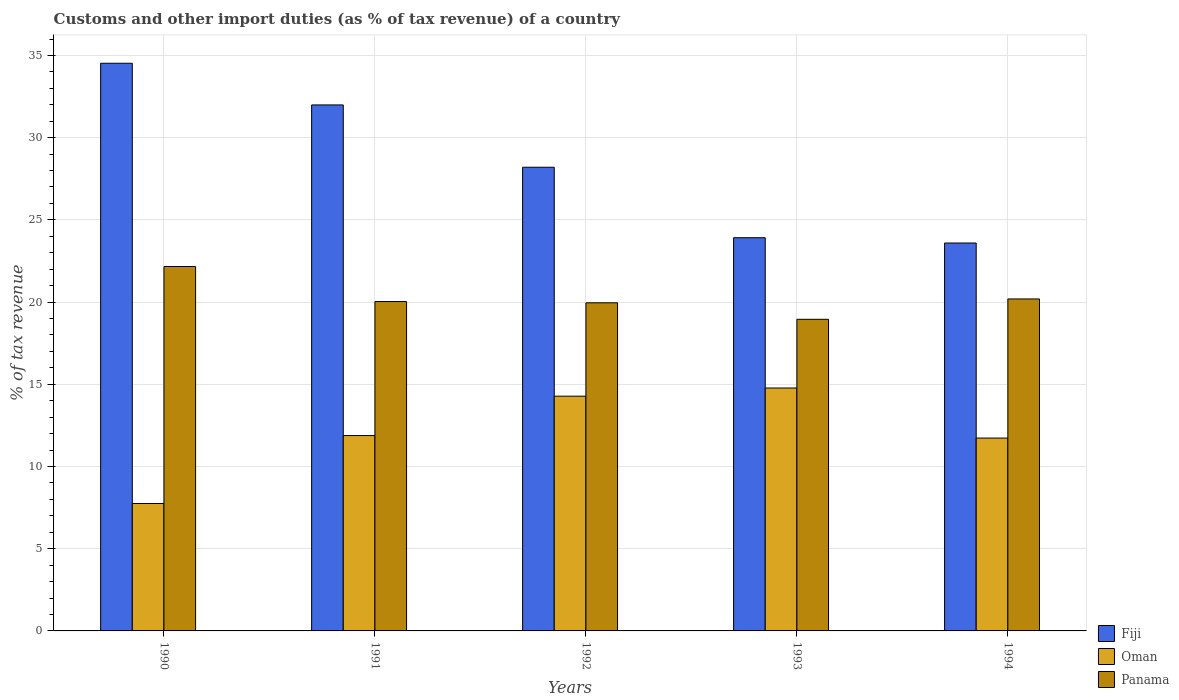How many different coloured bars are there?
Your answer should be very brief. 3. How many bars are there on the 1st tick from the left?
Keep it short and to the point. 3. What is the label of the 1st group of bars from the left?
Offer a terse response. 1990. In how many cases, is the number of bars for a given year not equal to the number of legend labels?
Ensure brevity in your answer.  0. What is the percentage of tax revenue from customs in Panama in 1990?
Provide a succinct answer. 22.16. Across all years, what is the maximum percentage of tax revenue from customs in Fiji?
Provide a succinct answer. 34.53. Across all years, what is the minimum percentage of tax revenue from customs in Oman?
Your answer should be very brief. 7.75. In which year was the percentage of tax revenue from customs in Panama maximum?
Make the answer very short. 1990. In which year was the percentage of tax revenue from customs in Fiji minimum?
Provide a short and direct response. 1994. What is the total percentage of tax revenue from customs in Oman in the graph?
Make the answer very short. 60.41. What is the difference between the percentage of tax revenue from customs in Fiji in 1992 and that in 1993?
Give a very brief answer. 4.29. What is the difference between the percentage of tax revenue from customs in Fiji in 1992 and the percentage of tax revenue from customs in Panama in 1993?
Offer a very short reply. 9.25. What is the average percentage of tax revenue from customs in Oman per year?
Offer a very short reply. 12.08. In the year 1994, what is the difference between the percentage of tax revenue from customs in Oman and percentage of tax revenue from customs in Fiji?
Offer a very short reply. -11.86. In how many years, is the percentage of tax revenue from customs in Panama greater than 5 %?
Offer a very short reply. 5. What is the ratio of the percentage of tax revenue from customs in Oman in 1991 to that in 1994?
Keep it short and to the point. 1.01. Is the percentage of tax revenue from customs in Oman in 1992 less than that in 1993?
Ensure brevity in your answer.  Yes. Is the difference between the percentage of tax revenue from customs in Oman in 1990 and 1991 greater than the difference between the percentage of tax revenue from customs in Fiji in 1990 and 1991?
Provide a short and direct response. No. What is the difference between the highest and the second highest percentage of tax revenue from customs in Fiji?
Keep it short and to the point. 2.53. What is the difference between the highest and the lowest percentage of tax revenue from customs in Fiji?
Your response must be concise. 10.93. Is the sum of the percentage of tax revenue from customs in Oman in 1990 and 1991 greater than the maximum percentage of tax revenue from customs in Panama across all years?
Make the answer very short. No. What does the 2nd bar from the left in 1994 represents?
Ensure brevity in your answer.  Oman. What does the 1st bar from the right in 1994 represents?
Provide a succinct answer. Panama. How many bars are there?
Provide a succinct answer. 15. Are the values on the major ticks of Y-axis written in scientific E-notation?
Provide a short and direct response. No. Does the graph contain any zero values?
Keep it short and to the point. No. Does the graph contain grids?
Keep it short and to the point. Yes. Where does the legend appear in the graph?
Make the answer very short. Bottom right. How many legend labels are there?
Ensure brevity in your answer.  3. How are the legend labels stacked?
Keep it short and to the point. Vertical. What is the title of the graph?
Your response must be concise. Customs and other import duties (as % of tax revenue) of a country. Does "Nepal" appear as one of the legend labels in the graph?
Keep it short and to the point. No. What is the label or title of the X-axis?
Your answer should be compact. Years. What is the label or title of the Y-axis?
Provide a succinct answer. % of tax revenue. What is the % of tax revenue in Fiji in 1990?
Offer a very short reply. 34.53. What is the % of tax revenue in Oman in 1990?
Make the answer very short. 7.75. What is the % of tax revenue of Panama in 1990?
Offer a very short reply. 22.16. What is the % of tax revenue of Fiji in 1991?
Offer a terse response. 31.99. What is the % of tax revenue in Oman in 1991?
Make the answer very short. 11.88. What is the % of tax revenue in Panama in 1991?
Offer a very short reply. 20.03. What is the % of tax revenue in Fiji in 1992?
Your answer should be very brief. 28.2. What is the % of tax revenue in Oman in 1992?
Your response must be concise. 14.28. What is the % of tax revenue of Panama in 1992?
Provide a succinct answer. 19.96. What is the % of tax revenue in Fiji in 1993?
Keep it short and to the point. 23.92. What is the % of tax revenue of Oman in 1993?
Give a very brief answer. 14.77. What is the % of tax revenue of Panama in 1993?
Make the answer very short. 18.95. What is the % of tax revenue of Fiji in 1994?
Make the answer very short. 23.59. What is the % of tax revenue of Oman in 1994?
Offer a very short reply. 11.73. What is the % of tax revenue in Panama in 1994?
Your response must be concise. 20.19. Across all years, what is the maximum % of tax revenue of Fiji?
Make the answer very short. 34.53. Across all years, what is the maximum % of tax revenue in Oman?
Your answer should be very brief. 14.77. Across all years, what is the maximum % of tax revenue of Panama?
Provide a short and direct response. 22.16. Across all years, what is the minimum % of tax revenue of Fiji?
Your response must be concise. 23.59. Across all years, what is the minimum % of tax revenue of Oman?
Provide a succinct answer. 7.75. Across all years, what is the minimum % of tax revenue in Panama?
Give a very brief answer. 18.95. What is the total % of tax revenue of Fiji in the graph?
Ensure brevity in your answer.  142.23. What is the total % of tax revenue in Oman in the graph?
Offer a very short reply. 60.41. What is the total % of tax revenue in Panama in the graph?
Ensure brevity in your answer.  101.3. What is the difference between the % of tax revenue of Fiji in 1990 and that in 1991?
Make the answer very short. 2.53. What is the difference between the % of tax revenue of Oman in 1990 and that in 1991?
Offer a very short reply. -4.13. What is the difference between the % of tax revenue in Panama in 1990 and that in 1991?
Your response must be concise. 2.13. What is the difference between the % of tax revenue in Fiji in 1990 and that in 1992?
Your answer should be compact. 6.32. What is the difference between the % of tax revenue in Oman in 1990 and that in 1992?
Your response must be concise. -6.53. What is the difference between the % of tax revenue of Panama in 1990 and that in 1992?
Offer a terse response. 2.21. What is the difference between the % of tax revenue of Fiji in 1990 and that in 1993?
Provide a short and direct response. 10.61. What is the difference between the % of tax revenue in Oman in 1990 and that in 1993?
Offer a very short reply. -7.02. What is the difference between the % of tax revenue of Panama in 1990 and that in 1993?
Make the answer very short. 3.21. What is the difference between the % of tax revenue of Fiji in 1990 and that in 1994?
Your response must be concise. 10.93. What is the difference between the % of tax revenue of Oman in 1990 and that in 1994?
Ensure brevity in your answer.  -3.98. What is the difference between the % of tax revenue in Panama in 1990 and that in 1994?
Provide a succinct answer. 1.97. What is the difference between the % of tax revenue of Fiji in 1991 and that in 1992?
Offer a terse response. 3.79. What is the difference between the % of tax revenue of Oman in 1991 and that in 1992?
Offer a very short reply. -2.4. What is the difference between the % of tax revenue in Panama in 1991 and that in 1992?
Your response must be concise. 0.08. What is the difference between the % of tax revenue in Fiji in 1991 and that in 1993?
Provide a succinct answer. 8.08. What is the difference between the % of tax revenue in Oman in 1991 and that in 1993?
Ensure brevity in your answer.  -2.89. What is the difference between the % of tax revenue in Panama in 1991 and that in 1993?
Ensure brevity in your answer.  1.08. What is the difference between the % of tax revenue in Fiji in 1991 and that in 1994?
Give a very brief answer. 8.4. What is the difference between the % of tax revenue in Oman in 1991 and that in 1994?
Offer a very short reply. 0.15. What is the difference between the % of tax revenue of Panama in 1991 and that in 1994?
Give a very brief answer. -0.16. What is the difference between the % of tax revenue in Fiji in 1992 and that in 1993?
Offer a terse response. 4.29. What is the difference between the % of tax revenue in Oman in 1992 and that in 1993?
Offer a very short reply. -0.5. What is the difference between the % of tax revenue in Panama in 1992 and that in 1993?
Provide a succinct answer. 1. What is the difference between the % of tax revenue in Fiji in 1992 and that in 1994?
Your answer should be very brief. 4.61. What is the difference between the % of tax revenue in Oman in 1992 and that in 1994?
Keep it short and to the point. 2.55. What is the difference between the % of tax revenue in Panama in 1992 and that in 1994?
Provide a short and direct response. -0.24. What is the difference between the % of tax revenue in Fiji in 1993 and that in 1994?
Keep it short and to the point. 0.32. What is the difference between the % of tax revenue in Oman in 1993 and that in 1994?
Keep it short and to the point. 3.04. What is the difference between the % of tax revenue of Panama in 1993 and that in 1994?
Offer a terse response. -1.24. What is the difference between the % of tax revenue in Fiji in 1990 and the % of tax revenue in Oman in 1991?
Provide a short and direct response. 22.64. What is the difference between the % of tax revenue of Fiji in 1990 and the % of tax revenue of Panama in 1991?
Offer a terse response. 14.49. What is the difference between the % of tax revenue in Oman in 1990 and the % of tax revenue in Panama in 1991?
Give a very brief answer. -12.28. What is the difference between the % of tax revenue of Fiji in 1990 and the % of tax revenue of Oman in 1992?
Provide a succinct answer. 20.25. What is the difference between the % of tax revenue of Fiji in 1990 and the % of tax revenue of Panama in 1992?
Offer a very short reply. 14.57. What is the difference between the % of tax revenue of Oman in 1990 and the % of tax revenue of Panama in 1992?
Provide a succinct answer. -12.21. What is the difference between the % of tax revenue in Fiji in 1990 and the % of tax revenue in Oman in 1993?
Make the answer very short. 19.75. What is the difference between the % of tax revenue in Fiji in 1990 and the % of tax revenue in Panama in 1993?
Ensure brevity in your answer.  15.57. What is the difference between the % of tax revenue in Oman in 1990 and the % of tax revenue in Panama in 1993?
Your answer should be compact. -11.2. What is the difference between the % of tax revenue in Fiji in 1990 and the % of tax revenue in Oman in 1994?
Offer a very short reply. 22.8. What is the difference between the % of tax revenue in Fiji in 1990 and the % of tax revenue in Panama in 1994?
Provide a short and direct response. 14.33. What is the difference between the % of tax revenue in Oman in 1990 and the % of tax revenue in Panama in 1994?
Your answer should be very brief. -12.44. What is the difference between the % of tax revenue in Fiji in 1991 and the % of tax revenue in Oman in 1992?
Your answer should be compact. 17.71. What is the difference between the % of tax revenue in Fiji in 1991 and the % of tax revenue in Panama in 1992?
Your answer should be compact. 12.04. What is the difference between the % of tax revenue of Oman in 1991 and the % of tax revenue of Panama in 1992?
Your response must be concise. -8.07. What is the difference between the % of tax revenue in Fiji in 1991 and the % of tax revenue in Oman in 1993?
Your response must be concise. 17.22. What is the difference between the % of tax revenue in Fiji in 1991 and the % of tax revenue in Panama in 1993?
Your answer should be compact. 13.04. What is the difference between the % of tax revenue of Oman in 1991 and the % of tax revenue of Panama in 1993?
Give a very brief answer. -7.07. What is the difference between the % of tax revenue of Fiji in 1991 and the % of tax revenue of Oman in 1994?
Give a very brief answer. 20.26. What is the difference between the % of tax revenue of Fiji in 1991 and the % of tax revenue of Panama in 1994?
Ensure brevity in your answer.  11.8. What is the difference between the % of tax revenue of Oman in 1991 and the % of tax revenue of Panama in 1994?
Provide a short and direct response. -8.31. What is the difference between the % of tax revenue in Fiji in 1992 and the % of tax revenue in Oman in 1993?
Your response must be concise. 13.43. What is the difference between the % of tax revenue in Fiji in 1992 and the % of tax revenue in Panama in 1993?
Keep it short and to the point. 9.25. What is the difference between the % of tax revenue of Oman in 1992 and the % of tax revenue of Panama in 1993?
Offer a very short reply. -4.68. What is the difference between the % of tax revenue of Fiji in 1992 and the % of tax revenue of Oman in 1994?
Provide a short and direct response. 16.47. What is the difference between the % of tax revenue in Fiji in 1992 and the % of tax revenue in Panama in 1994?
Your answer should be compact. 8.01. What is the difference between the % of tax revenue in Oman in 1992 and the % of tax revenue in Panama in 1994?
Make the answer very short. -5.91. What is the difference between the % of tax revenue in Fiji in 1993 and the % of tax revenue in Oman in 1994?
Provide a succinct answer. 12.19. What is the difference between the % of tax revenue of Fiji in 1993 and the % of tax revenue of Panama in 1994?
Your response must be concise. 3.72. What is the difference between the % of tax revenue of Oman in 1993 and the % of tax revenue of Panama in 1994?
Provide a short and direct response. -5.42. What is the average % of tax revenue in Fiji per year?
Your response must be concise. 28.45. What is the average % of tax revenue in Oman per year?
Keep it short and to the point. 12.08. What is the average % of tax revenue of Panama per year?
Offer a very short reply. 20.26. In the year 1990, what is the difference between the % of tax revenue of Fiji and % of tax revenue of Oman?
Offer a terse response. 26.77. In the year 1990, what is the difference between the % of tax revenue of Fiji and % of tax revenue of Panama?
Provide a succinct answer. 12.36. In the year 1990, what is the difference between the % of tax revenue of Oman and % of tax revenue of Panama?
Provide a succinct answer. -14.41. In the year 1991, what is the difference between the % of tax revenue in Fiji and % of tax revenue in Oman?
Offer a very short reply. 20.11. In the year 1991, what is the difference between the % of tax revenue in Fiji and % of tax revenue in Panama?
Offer a terse response. 11.96. In the year 1991, what is the difference between the % of tax revenue of Oman and % of tax revenue of Panama?
Offer a terse response. -8.15. In the year 1992, what is the difference between the % of tax revenue in Fiji and % of tax revenue in Oman?
Make the answer very short. 13.92. In the year 1992, what is the difference between the % of tax revenue in Fiji and % of tax revenue in Panama?
Your answer should be very brief. 8.24. In the year 1992, what is the difference between the % of tax revenue in Oman and % of tax revenue in Panama?
Give a very brief answer. -5.68. In the year 1993, what is the difference between the % of tax revenue in Fiji and % of tax revenue in Oman?
Keep it short and to the point. 9.14. In the year 1993, what is the difference between the % of tax revenue in Fiji and % of tax revenue in Panama?
Provide a short and direct response. 4.96. In the year 1993, what is the difference between the % of tax revenue of Oman and % of tax revenue of Panama?
Offer a very short reply. -4.18. In the year 1994, what is the difference between the % of tax revenue in Fiji and % of tax revenue in Oman?
Offer a very short reply. 11.86. In the year 1994, what is the difference between the % of tax revenue of Fiji and % of tax revenue of Panama?
Your response must be concise. 3.4. In the year 1994, what is the difference between the % of tax revenue in Oman and % of tax revenue in Panama?
Your answer should be compact. -8.46. What is the ratio of the % of tax revenue of Fiji in 1990 to that in 1991?
Ensure brevity in your answer.  1.08. What is the ratio of the % of tax revenue of Oman in 1990 to that in 1991?
Provide a succinct answer. 0.65. What is the ratio of the % of tax revenue in Panama in 1990 to that in 1991?
Provide a short and direct response. 1.11. What is the ratio of the % of tax revenue in Fiji in 1990 to that in 1992?
Provide a succinct answer. 1.22. What is the ratio of the % of tax revenue in Oman in 1990 to that in 1992?
Keep it short and to the point. 0.54. What is the ratio of the % of tax revenue of Panama in 1990 to that in 1992?
Ensure brevity in your answer.  1.11. What is the ratio of the % of tax revenue of Fiji in 1990 to that in 1993?
Provide a short and direct response. 1.44. What is the ratio of the % of tax revenue in Oman in 1990 to that in 1993?
Provide a succinct answer. 0.52. What is the ratio of the % of tax revenue in Panama in 1990 to that in 1993?
Keep it short and to the point. 1.17. What is the ratio of the % of tax revenue in Fiji in 1990 to that in 1994?
Make the answer very short. 1.46. What is the ratio of the % of tax revenue of Oman in 1990 to that in 1994?
Ensure brevity in your answer.  0.66. What is the ratio of the % of tax revenue of Panama in 1990 to that in 1994?
Make the answer very short. 1.1. What is the ratio of the % of tax revenue of Fiji in 1991 to that in 1992?
Provide a succinct answer. 1.13. What is the ratio of the % of tax revenue in Oman in 1991 to that in 1992?
Provide a short and direct response. 0.83. What is the ratio of the % of tax revenue in Fiji in 1991 to that in 1993?
Offer a terse response. 1.34. What is the ratio of the % of tax revenue of Oman in 1991 to that in 1993?
Your response must be concise. 0.8. What is the ratio of the % of tax revenue in Panama in 1991 to that in 1993?
Offer a terse response. 1.06. What is the ratio of the % of tax revenue of Fiji in 1991 to that in 1994?
Offer a terse response. 1.36. What is the ratio of the % of tax revenue in Oman in 1991 to that in 1994?
Ensure brevity in your answer.  1.01. What is the ratio of the % of tax revenue of Fiji in 1992 to that in 1993?
Keep it short and to the point. 1.18. What is the ratio of the % of tax revenue in Oman in 1992 to that in 1993?
Your response must be concise. 0.97. What is the ratio of the % of tax revenue in Panama in 1992 to that in 1993?
Make the answer very short. 1.05. What is the ratio of the % of tax revenue in Fiji in 1992 to that in 1994?
Your answer should be very brief. 1.2. What is the ratio of the % of tax revenue in Oman in 1992 to that in 1994?
Provide a succinct answer. 1.22. What is the ratio of the % of tax revenue in Panama in 1992 to that in 1994?
Give a very brief answer. 0.99. What is the ratio of the % of tax revenue of Fiji in 1993 to that in 1994?
Your answer should be compact. 1.01. What is the ratio of the % of tax revenue of Oman in 1993 to that in 1994?
Keep it short and to the point. 1.26. What is the ratio of the % of tax revenue of Panama in 1993 to that in 1994?
Your response must be concise. 0.94. What is the difference between the highest and the second highest % of tax revenue in Fiji?
Provide a short and direct response. 2.53. What is the difference between the highest and the second highest % of tax revenue in Oman?
Provide a succinct answer. 0.5. What is the difference between the highest and the second highest % of tax revenue in Panama?
Ensure brevity in your answer.  1.97. What is the difference between the highest and the lowest % of tax revenue in Fiji?
Give a very brief answer. 10.93. What is the difference between the highest and the lowest % of tax revenue in Oman?
Make the answer very short. 7.02. What is the difference between the highest and the lowest % of tax revenue in Panama?
Offer a terse response. 3.21. 